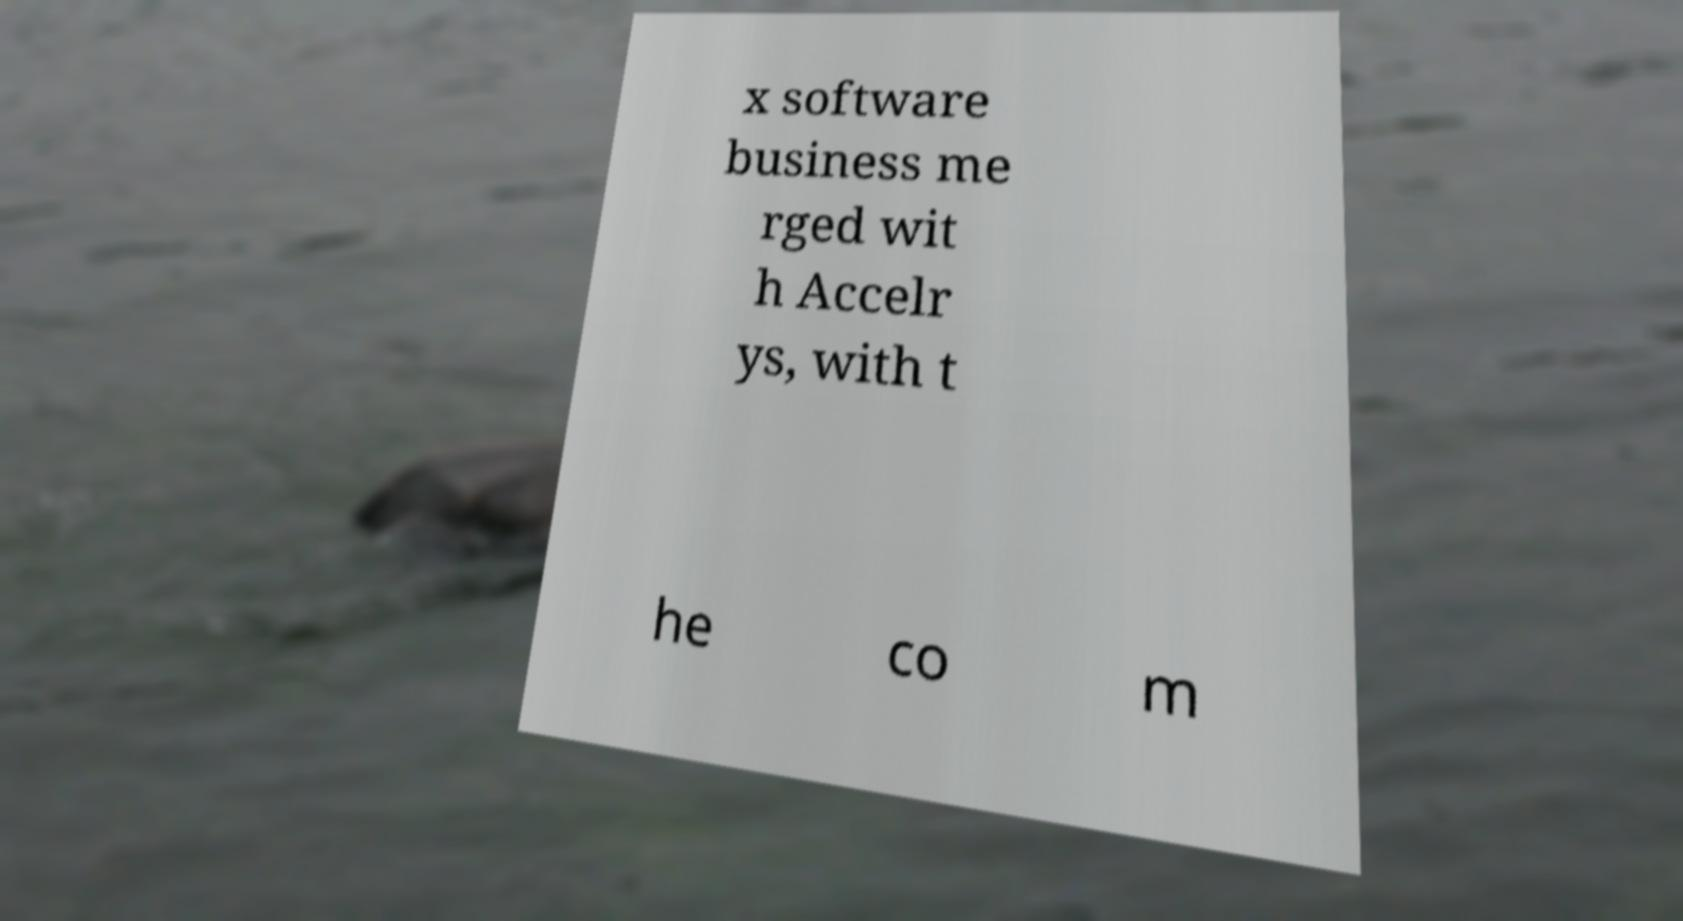Can you read and provide the text displayed in the image?This photo seems to have some interesting text. Can you extract and type it out for me? x software business me rged wit h Accelr ys, with t he co m 